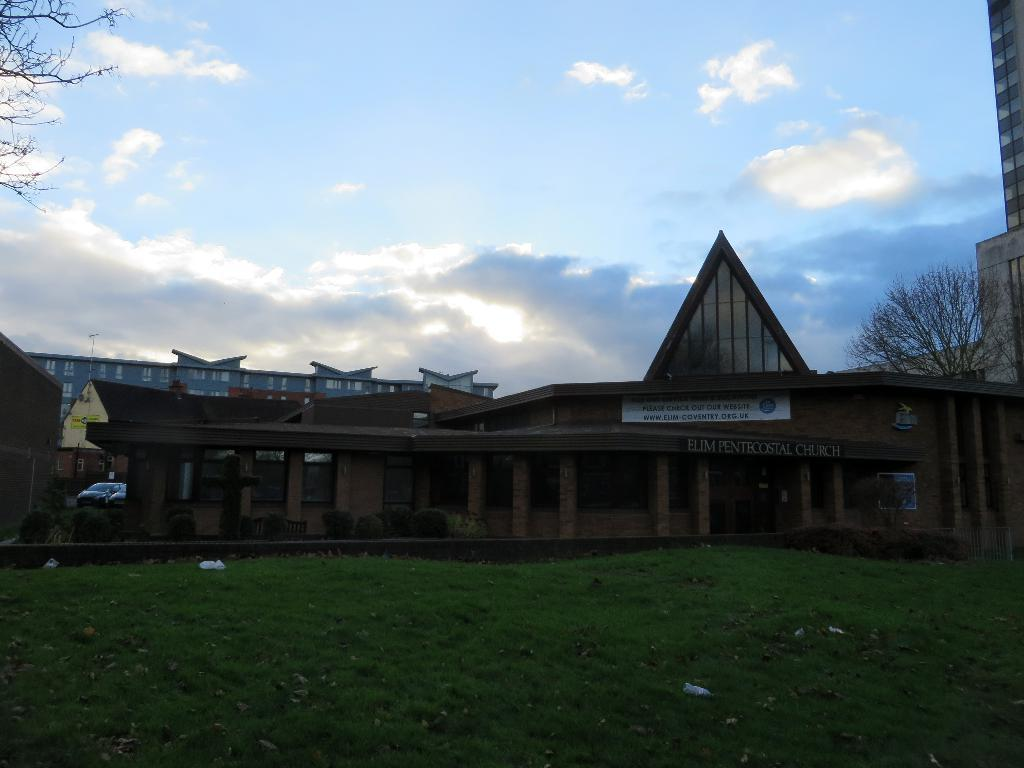What type of structures are present in the image? There are buildings in the image. What colors are the buildings? The buildings are in brown and gray colors. What type of vegetation can be seen in the image? There is grass in the image. What color is the grass? The grass is green. What type of trees are present in the image? There are dried trees in the image. What colors are visible in the sky? The sky is in white and blue colors. What type of camp can be seen in the image? There is no camp present in the image; it features buildings, grass, dried trees, and a sky with white and blue colors. What scientific theory is being demonstrated in the image? There is no scientific theory being demonstrated in the image; it is a scene with buildings, grass, dried trees, and a sky with white and blue colors. 